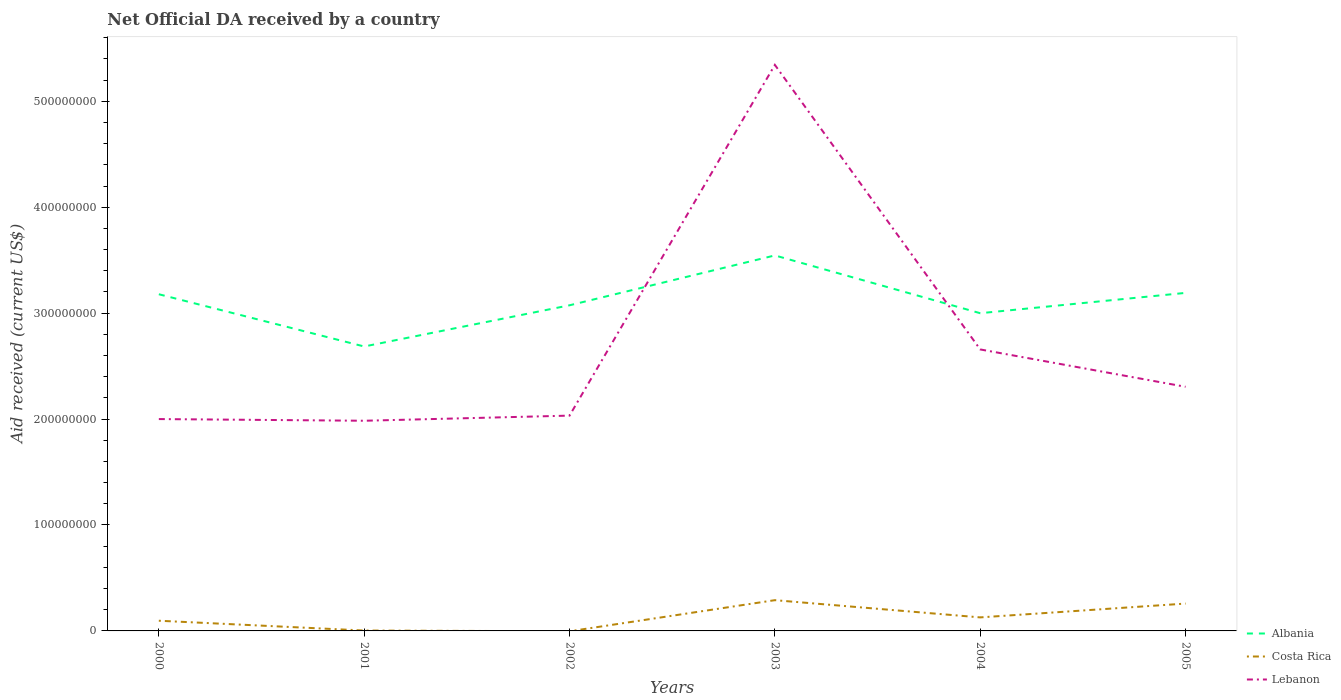Does the line corresponding to Albania intersect with the line corresponding to Lebanon?
Offer a very short reply. Yes. Across all years, what is the maximum net official development assistance aid received in Albania?
Your answer should be very brief. 2.69e+08. What is the total net official development assistance aid received in Lebanon in the graph?
Your answer should be compact. -3.26e+06. What is the difference between the highest and the second highest net official development assistance aid received in Albania?
Make the answer very short. 8.60e+07. How many lines are there?
Your answer should be very brief. 3. How many years are there in the graph?
Ensure brevity in your answer.  6. What is the difference between two consecutive major ticks on the Y-axis?
Provide a succinct answer. 1.00e+08. Are the values on the major ticks of Y-axis written in scientific E-notation?
Ensure brevity in your answer.  No. How are the legend labels stacked?
Provide a short and direct response. Vertical. What is the title of the graph?
Offer a terse response. Net Official DA received by a country. Does "Ireland" appear as one of the legend labels in the graph?
Provide a short and direct response. No. What is the label or title of the Y-axis?
Give a very brief answer. Aid received (current US$). What is the Aid received (current US$) in Albania in 2000?
Your response must be concise. 3.18e+08. What is the Aid received (current US$) of Costa Rica in 2000?
Offer a very short reply. 9.62e+06. What is the Aid received (current US$) in Lebanon in 2000?
Give a very brief answer. 2.00e+08. What is the Aid received (current US$) in Albania in 2001?
Make the answer very short. 2.69e+08. What is the Aid received (current US$) in Lebanon in 2001?
Your response must be concise. 1.98e+08. What is the Aid received (current US$) of Albania in 2002?
Make the answer very short. 3.07e+08. What is the Aid received (current US$) of Costa Rica in 2002?
Keep it short and to the point. 0. What is the Aid received (current US$) of Lebanon in 2002?
Provide a short and direct response. 2.03e+08. What is the Aid received (current US$) of Albania in 2003?
Provide a succinct answer. 3.54e+08. What is the Aid received (current US$) of Costa Rica in 2003?
Ensure brevity in your answer.  2.90e+07. What is the Aid received (current US$) of Lebanon in 2003?
Ensure brevity in your answer.  5.34e+08. What is the Aid received (current US$) in Albania in 2004?
Provide a succinct answer. 3.00e+08. What is the Aid received (current US$) of Costa Rica in 2004?
Keep it short and to the point. 1.28e+07. What is the Aid received (current US$) in Lebanon in 2004?
Provide a short and direct response. 2.66e+08. What is the Aid received (current US$) of Albania in 2005?
Your answer should be very brief. 3.19e+08. What is the Aid received (current US$) in Costa Rica in 2005?
Ensure brevity in your answer.  2.58e+07. What is the Aid received (current US$) in Lebanon in 2005?
Your answer should be very brief. 2.30e+08. Across all years, what is the maximum Aid received (current US$) in Albania?
Make the answer very short. 3.54e+08. Across all years, what is the maximum Aid received (current US$) in Costa Rica?
Provide a succinct answer. 2.90e+07. Across all years, what is the maximum Aid received (current US$) of Lebanon?
Keep it short and to the point. 5.34e+08. Across all years, what is the minimum Aid received (current US$) of Albania?
Offer a terse response. 2.69e+08. Across all years, what is the minimum Aid received (current US$) in Costa Rica?
Your answer should be compact. 0. Across all years, what is the minimum Aid received (current US$) in Lebanon?
Your answer should be very brief. 1.98e+08. What is the total Aid received (current US$) in Albania in the graph?
Offer a very short reply. 1.87e+09. What is the total Aid received (current US$) in Costa Rica in the graph?
Keep it short and to the point. 7.76e+07. What is the total Aid received (current US$) in Lebanon in the graph?
Provide a short and direct response. 1.63e+09. What is the difference between the Aid received (current US$) of Albania in 2000 and that in 2001?
Keep it short and to the point. 4.93e+07. What is the difference between the Aid received (current US$) of Costa Rica in 2000 and that in 2001?
Give a very brief answer. 9.25e+06. What is the difference between the Aid received (current US$) in Lebanon in 2000 and that in 2001?
Your response must be concise. 1.59e+06. What is the difference between the Aid received (current US$) in Albania in 2000 and that in 2002?
Give a very brief answer. 1.04e+07. What is the difference between the Aid received (current US$) in Lebanon in 2000 and that in 2002?
Make the answer very short. -3.26e+06. What is the difference between the Aid received (current US$) in Albania in 2000 and that in 2003?
Your response must be concise. -3.66e+07. What is the difference between the Aid received (current US$) in Costa Rica in 2000 and that in 2003?
Offer a very short reply. -1.94e+07. What is the difference between the Aid received (current US$) in Lebanon in 2000 and that in 2003?
Your answer should be very brief. -3.34e+08. What is the difference between the Aid received (current US$) of Albania in 2000 and that in 2004?
Offer a very short reply. 1.79e+07. What is the difference between the Aid received (current US$) in Costa Rica in 2000 and that in 2004?
Your answer should be very brief. -3.15e+06. What is the difference between the Aid received (current US$) of Lebanon in 2000 and that in 2004?
Make the answer very short. -6.57e+07. What is the difference between the Aid received (current US$) in Albania in 2000 and that in 2005?
Your answer should be compact. -1.29e+06. What is the difference between the Aid received (current US$) in Costa Rica in 2000 and that in 2005?
Make the answer very short. -1.62e+07. What is the difference between the Aid received (current US$) in Lebanon in 2000 and that in 2005?
Your response must be concise. -3.05e+07. What is the difference between the Aid received (current US$) in Albania in 2001 and that in 2002?
Offer a terse response. -3.89e+07. What is the difference between the Aid received (current US$) of Lebanon in 2001 and that in 2002?
Offer a terse response. -4.85e+06. What is the difference between the Aid received (current US$) of Albania in 2001 and that in 2003?
Your answer should be compact. -8.60e+07. What is the difference between the Aid received (current US$) of Costa Rica in 2001 and that in 2003?
Your answer should be compact. -2.87e+07. What is the difference between the Aid received (current US$) in Lebanon in 2001 and that in 2003?
Your answer should be compact. -3.36e+08. What is the difference between the Aid received (current US$) of Albania in 2001 and that in 2004?
Provide a succinct answer. -3.14e+07. What is the difference between the Aid received (current US$) of Costa Rica in 2001 and that in 2004?
Give a very brief answer. -1.24e+07. What is the difference between the Aid received (current US$) in Lebanon in 2001 and that in 2004?
Your answer should be compact. -6.73e+07. What is the difference between the Aid received (current US$) of Albania in 2001 and that in 2005?
Ensure brevity in your answer.  -5.06e+07. What is the difference between the Aid received (current US$) in Costa Rica in 2001 and that in 2005?
Your response must be concise. -2.54e+07. What is the difference between the Aid received (current US$) of Lebanon in 2001 and that in 2005?
Give a very brief answer. -3.21e+07. What is the difference between the Aid received (current US$) in Albania in 2002 and that in 2003?
Provide a short and direct response. -4.71e+07. What is the difference between the Aid received (current US$) in Lebanon in 2002 and that in 2003?
Provide a short and direct response. -3.31e+08. What is the difference between the Aid received (current US$) in Albania in 2002 and that in 2004?
Your response must be concise. 7.47e+06. What is the difference between the Aid received (current US$) of Lebanon in 2002 and that in 2004?
Give a very brief answer. -6.25e+07. What is the difference between the Aid received (current US$) in Albania in 2002 and that in 2005?
Offer a very short reply. -1.17e+07. What is the difference between the Aid received (current US$) of Lebanon in 2002 and that in 2005?
Give a very brief answer. -2.72e+07. What is the difference between the Aid received (current US$) of Albania in 2003 and that in 2004?
Your response must be concise. 5.46e+07. What is the difference between the Aid received (current US$) of Costa Rica in 2003 and that in 2004?
Offer a terse response. 1.63e+07. What is the difference between the Aid received (current US$) in Lebanon in 2003 and that in 2004?
Your answer should be very brief. 2.69e+08. What is the difference between the Aid received (current US$) in Albania in 2003 and that in 2005?
Offer a terse response. 3.54e+07. What is the difference between the Aid received (current US$) of Costa Rica in 2003 and that in 2005?
Provide a short and direct response. 3.21e+06. What is the difference between the Aid received (current US$) in Lebanon in 2003 and that in 2005?
Provide a short and direct response. 3.04e+08. What is the difference between the Aid received (current US$) of Albania in 2004 and that in 2005?
Your answer should be very brief. -1.92e+07. What is the difference between the Aid received (current US$) of Costa Rica in 2004 and that in 2005?
Your answer should be very brief. -1.30e+07. What is the difference between the Aid received (current US$) of Lebanon in 2004 and that in 2005?
Ensure brevity in your answer.  3.53e+07. What is the difference between the Aid received (current US$) of Albania in 2000 and the Aid received (current US$) of Costa Rica in 2001?
Your response must be concise. 3.17e+08. What is the difference between the Aid received (current US$) in Albania in 2000 and the Aid received (current US$) in Lebanon in 2001?
Keep it short and to the point. 1.19e+08. What is the difference between the Aid received (current US$) in Costa Rica in 2000 and the Aid received (current US$) in Lebanon in 2001?
Ensure brevity in your answer.  -1.89e+08. What is the difference between the Aid received (current US$) in Albania in 2000 and the Aid received (current US$) in Lebanon in 2002?
Offer a terse response. 1.15e+08. What is the difference between the Aid received (current US$) in Costa Rica in 2000 and the Aid received (current US$) in Lebanon in 2002?
Keep it short and to the point. -1.94e+08. What is the difference between the Aid received (current US$) in Albania in 2000 and the Aid received (current US$) in Costa Rica in 2003?
Your answer should be compact. 2.89e+08. What is the difference between the Aid received (current US$) in Albania in 2000 and the Aid received (current US$) in Lebanon in 2003?
Your answer should be very brief. -2.17e+08. What is the difference between the Aid received (current US$) of Costa Rica in 2000 and the Aid received (current US$) of Lebanon in 2003?
Make the answer very short. -5.25e+08. What is the difference between the Aid received (current US$) of Albania in 2000 and the Aid received (current US$) of Costa Rica in 2004?
Give a very brief answer. 3.05e+08. What is the difference between the Aid received (current US$) in Albania in 2000 and the Aid received (current US$) in Lebanon in 2004?
Offer a very short reply. 5.21e+07. What is the difference between the Aid received (current US$) of Costa Rica in 2000 and the Aid received (current US$) of Lebanon in 2004?
Offer a terse response. -2.56e+08. What is the difference between the Aid received (current US$) in Albania in 2000 and the Aid received (current US$) in Costa Rica in 2005?
Ensure brevity in your answer.  2.92e+08. What is the difference between the Aid received (current US$) in Albania in 2000 and the Aid received (current US$) in Lebanon in 2005?
Offer a very short reply. 8.74e+07. What is the difference between the Aid received (current US$) in Costa Rica in 2000 and the Aid received (current US$) in Lebanon in 2005?
Provide a succinct answer. -2.21e+08. What is the difference between the Aid received (current US$) in Albania in 2001 and the Aid received (current US$) in Lebanon in 2002?
Offer a terse response. 6.53e+07. What is the difference between the Aid received (current US$) in Costa Rica in 2001 and the Aid received (current US$) in Lebanon in 2002?
Make the answer very short. -2.03e+08. What is the difference between the Aid received (current US$) in Albania in 2001 and the Aid received (current US$) in Costa Rica in 2003?
Keep it short and to the point. 2.40e+08. What is the difference between the Aid received (current US$) in Albania in 2001 and the Aid received (current US$) in Lebanon in 2003?
Your response must be concise. -2.66e+08. What is the difference between the Aid received (current US$) in Costa Rica in 2001 and the Aid received (current US$) in Lebanon in 2003?
Your answer should be very brief. -5.34e+08. What is the difference between the Aid received (current US$) in Albania in 2001 and the Aid received (current US$) in Costa Rica in 2004?
Your answer should be compact. 2.56e+08. What is the difference between the Aid received (current US$) of Albania in 2001 and the Aid received (current US$) of Lebanon in 2004?
Provide a short and direct response. 2.78e+06. What is the difference between the Aid received (current US$) in Costa Rica in 2001 and the Aid received (current US$) in Lebanon in 2004?
Give a very brief answer. -2.65e+08. What is the difference between the Aid received (current US$) in Albania in 2001 and the Aid received (current US$) in Costa Rica in 2005?
Offer a very short reply. 2.43e+08. What is the difference between the Aid received (current US$) of Albania in 2001 and the Aid received (current US$) of Lebanon in 2005?
Your answer should be very brief. 3.80e+07. What is the difference between the Aid received (current US$) of Costa Rica in 2001 and the Aid received (current US$) of Lebanon in 2005?
Provide a succinct answer. -2.30e+08. What is the difference between the Aid received (current US$) of Albania in 2002 and the Aid received (current US$) of Costa Rica in 2003?
Your answer should be compact. 2.78e+08. What is the difference between the Aid received (current US$) of Albania in 2002 and the Aid received (current US$) of Lebanon in 2003?
Provide a short and direct response. -2.27e+08. What is the difference between the Aid received (current US$) in Albania in 2002 and the Aid received (current US$) in Costa Rica in 2004?
Offer a very short reply. 2.95e+08. What is the difference between the Aid received (current US$) of Albania in 2002 and the Aid received (current US$) of Lebanon in 2004?
Your answer should be compact. 4.17e+07. What is the difference between the Aid received (current US$) in Albania in 2002 and the Aid received (current US$) in Costa Rica in 2005?
Keep it short and to the point. 2.82e+08. What is the difference between the Aid received (current US$) of Albania in 2002 and the Aid received (current US$) of Lebanon in 2005?
Your answer should be compact. 7.69e+07. What is the difference between the Aid received (current US$) of Albania in 2003 and the Aid received (current US$) of Costa Rica in 2004?
Make the answer very short. 3.42e+08. What is the difference between the Aid received (current US$) of Albania in 2003 and the Aid received (current US$) of Lebanon in 2004?
Your answer should be very brief. 8.88e+07. What is the difference between the Aid received (current US$) in Costa Rica in 2003 and the Aid received (current US$) in Lebanon in 2004?
Your answer should be compact. -2.37e+08. What is the difference between the Aid received (current US$) in Albania in 2003 and the Aid received (current US$) in Costa Rica in 2005?
Your answer should be compact. 3.29e+08. What is the difference between the Aid received (current US$) of Albania in 2003 and the Aid received (current US$) of Lebanon in 2005?
Give a very brief answer. 1.24e+08. What is the difference between the Aid received (current US$) in Costa Rica in 2003 and the Aid received (current US$) in Lebanon in 2005?
Provide a succinct answer. -2.01e+08. What is the difference between the Aid received (current US$) of Albania in 2004 and the Aid received (current US$) of Costa Rica in 2005?
Keep it short and to the point. 2.74e+08. What is the difference between the Aid received (current US$) in Albania in 2004 and the Aid received (current US$) in Lebanon in 2005?
Offer a very short reply. 6.95e+07. What is the difference between the Aid received (current US$) of Costa Rica in 2004 and the Aid received (current US$) of Lebanon in 2005?
Your response must be concise. -2.18e+08. What is the average Aid received (current US$) of Albania per year?
Offer a very short reply. 3.11e+08. What is the average Aid received (current US$) in Costa Rica per year?
Give a very brief answer. 1.29e+07. What is the average Aid received (current US$) of Lebanon per year?
Your answer should be compact. 2.72e+08. In the year 2000, what is the difference between the Aid received (current US$) in Albania and Aid received (current US$) in Costa Rica?
Ensure brevity in your answer.  3.08e+08. In the year 2000, what is the difference between the Aid received (current US$) in Albania and Aid received (current US$) in Lebanon?
Make the answer very short. 1.18e+08. In the year 2000, what is the difference between the Aid received (current US$) in Costa Rica and Aid received (current US$) in Lebanon?
Provide a short and direct response. -1.90e+08. In the year 2001, what is the difference between the Aid received (current US$) in Albania and Aid received (current US$) in Costa Rica?
Your answer should be very brief. 2.68e+08. In the year 2001, what is the difference between the Aid received (current US$) of Albania and Aid received (current US$) of Lebanon?
Your answer should be very brief. 7.01e+07. In the year 2001, what is the difference between the Aid received (current US$) of Costa Rica and Aid received (current US$) of Lebanon?
Offer a terse response. -1.98e+08. In the year 2002, what is the difference between the Aid received (current US$) of Albania and Aid received (current US$) of Lebanon?
Provide a short and direct response. 1.04e+08. In the year 2003, what is the difference between the Aid received (current US$) of Albania and Aid received (current US$) of Costa Rica?
Your response must be concise. 3.25e+08. In the year 2003, what is the difference between the Aid received (current US$) in Albania and Aid received (current US$) in Lebanon?
Your answer should be compact. -1.80e+08. In the year 2003, what is the difference between the Aid received (current US$) in Costa Rica and Aid received (current US$) in Lebanon?
Offer a terse response. -5.05e+08. In the year 2004, what is the difference between the Aid received (current US$) of Albania and Aid received (current US$) of Costa Rica?
Your response must be concise. 2.87e+08. In the year 2004, what is the difference between the Aid received (current US$) in Albania and Aid received (current US$) in Lebanon?
Ensure brevity in your answer.  3.42e+07. In the year 2004, what is the difference between the Aid received (current US$) of Costa Rica and Aid received (current US$) of Lebanon?
Give a very brief answer. -2.53e+08. In the year 2005, what is the difference between the Aid received (current US$) of Albania and Aid received (current US$) of Costa Rica?
Give a very brief answer. 2.93e+08. In the year 2005, what is the difference between the Aid received (current US$) of Albania and Aid received (current US$) of Lebanon?
Your answer should be very brief. 8.87e+07. In the year 2005, what is the difference between the Aid received (current US$) of Costa Rica and Aid received (current US$) of Lebanon?
Give a very brief answer. -2.05e+08. What is the ratio of the Aid received (current US$) of Albania in 2000 to that in 2001?
Keep it short and to the point. 1.18. What is the ratio of the Aid received (current US$) of Lebanon in 2000 to that in 2001?
Ensure brevity in your answer.  1.01. What is the ratio of the Aid received (current US$) of Albania in 2000 to that in 2002?
Provide a short and direct response. 1.03. What is the ratio of the Aid received (current US$) of Albania in 2000 to that in 2003?
Make the answer very short. 0.9. What is the ratio of the Aid received (current US$) in Costa Rica in 2000 to that in 2003?
Provide a succinct answer. 0.33. What is the ratio of the Aid received (current US$) in Lebanon in 2000 to that in 2003?
Keep it short and to the point. 0.37. What is the ratio of the Aid received (current US$) in Albania in 2000 to that in 2004?
Offer a terse response. 1.06. What is the ratio of the Aid received (current US$) of Costa Rica in 2000 to that in 2004?
Your answer should be compact. 0.75. What is the ratio of the Aid received (current US$) in Lebanon in 2000 to that in 2004?
Provide a short and direct response. 0.75. What is the ratio of the Aid received (current US$) of Costa Rica in 2000 to that in 2005?
Provide a succinct answer. 0.37. What is the ratio of the Aid received (current US$) in Lebanon in 2000 to that in 2005?
Give a very brief answer. 0.87. What is the ratio of the Aid received (current US$) in Albania in 2001 to that in 2002?
Ensure brevity in your answer.  0.87. What is the ratio of the Aid received (current US$) in Lebanon in 2001 to that in 2002?
Ensure brevity in your answer.  0.98. What is the ratio of the Aid received (current US$) of Albania in 2001 to that in 2003?
Provide a succinct answer. 0.76. What is the ratio of the Aid received (current US$) of Costa Rica in 2001 to that in 2003?
Your response must be concise. 0.01. What is the ratio of the Aid received (current US$) in Lebanon in 2001 to that in 2003?
Ensure brevity in your answer.  0.37. What is the ratio of the Aid received (current US$) in Albania in 2001 to that in 2004?
Your response must be concise. 0.9. What is the ratio of the Aid received (current US$) of Costa Rica in 2001 to that in 2004?
Provide a succinct answer. 0.03. What is the ratio of the Aid received (current US$) of Lebanon in 2001 to that in 2004?
Your answer should be compact. 0.75. What is the ratio of the Aid received (current US$) in Albania in 2001 to that in 2005?
Your answer should be compact. 0.84. What is the ratio of the Aid received (current US$) in Costa Rica in 2001 to that in 2005?
Provide a short and direct response. 0.01. What is the ratio of the Aid received (current US$) of Lebanon in 2001 to that in 2005?
Ensure brevity in your answer.  0.86. What is the ratio of the Aid received (current US$) in Albania in 2002 to that in 2003?
Keep it short and to the point. 0.87. What is the ratio of the Aid received (current US$) of Lebanon in 2002 to that in 2003?
Offer a terse response. 0.38. What is the ratio of the Aid received (current US$) of Albania in 2002 to that in 2004?
Keep it short and to the point. 1.02. What is the ratio of the Aid received (current US$) in Lebanon in 2002 to that in 2004?
Your answer should be very brief. 0.76. What is the ratio of the Aid received (current US$) in Albania in 2002 to that in 2005?
Make the answer very short. 0.96. What is the ratio of the Aid received (current US$) in Lebanon in 2002 to that in 2005?
Your answer should be compact. 0.88. What is the ratio of the Aid received (current US$) of Albania in 2003 to that in 2004?
Your answer should be very brief. 1.18. What is the ratio of the Aid received (current US$) of Costa Rica in 2003 to that in 2004?
Provide a short and direct response. 2.27. What is the ratio of the Aid received (current US$) in Lebanon in 2003 to that in 2004?
Ensure brevity in your answer.  2.01. What is the ratio of the Aid received (current US$) of Albania in 2003 to that in 2005?
Offer a very short reply. 1.11. What is the ratio of the Aid received (current US$) of Costa Rica in 2003 to that in 2005?
Ensure brevity in your answer.  1.12. What is the ratio of the Aid received (current US$) in Lebanon in 2003 to that in 2005?
Your response must be concise. 2.32. What is the ratio of the Aid received (current US$) in Albania in 2004 to that in 2005?
Make the answer very short. 0.94. What is the ratio of the Aid received (current US$) in Costa Rica in 2004 to that in 2005?
Give a very brief answer. 0.49. What is the ratio of the Aid received (current US$) in Lebanon in 2004 to that in 2005?
Ensure brevity in your answer.  1.15. What is the difference between the highest and the second highest Aid received (current US$) of Albania?
Make the answer very short. 3.54e+07. What is the difference between the highest and the second highest Aid received (current US$) in Costa Rica?
Give a very brief answer. 3.21e+06. What is the difference between the highest and the second highest Aid received (current US$) of Lebanon?
Keep it short and to the point. 2.69e+08. What is the difference between the highest and the lowest Aid received (current US$) of Albania?
Ensure brevity in your answer.  8.60e+07. What is the difference between the highest and the lowest Aid received (current US$) of Costa Rica?
Your response must be concise. 2.90e+07. What is the difference between the highest and the lowest Aid received (current US$) of Lebanon?
Give a very brief answer. 3.36e+08. 